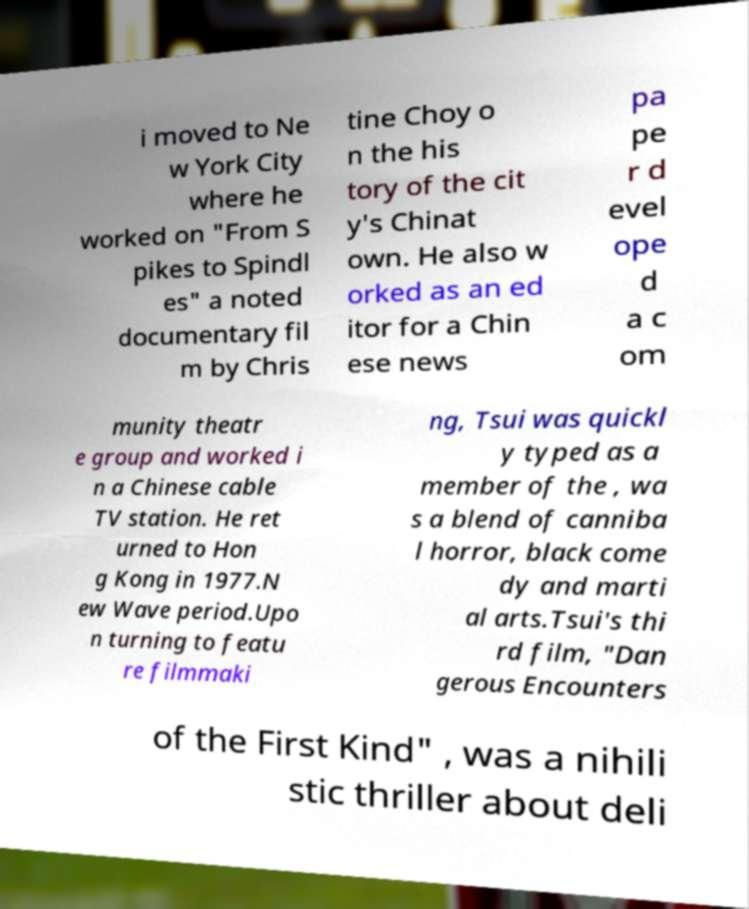Please read and relay the text visible in this image. What does it say? i moved to Ne w York City where he worked on "From S pikes to Spindl es" a noted documentary fil m by Chris tine Choy o n the his tory of the cit y's Chinat own. He also w orked as an ed itor for a Chin ese news pa pe r d evel ope d a c om munity theatr e group and worked i n a Chinese cable TV station. He ret urned to Hon g Kong in 1977.N ew Wave period.Upo n turning to featu re filmmaki ng, Tsui was quickl y typed as a member of the , wa s a blend of canniba l horror, black come dy and marti al arts.Tsui's thi rd film, "Dan gerous Encounters of the First Kind" , was a nihili stic thriller about deli 